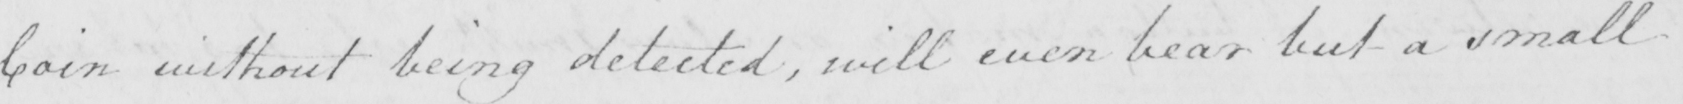What text is written in this handwritten line? Coin without being detected , will even bear but a small 